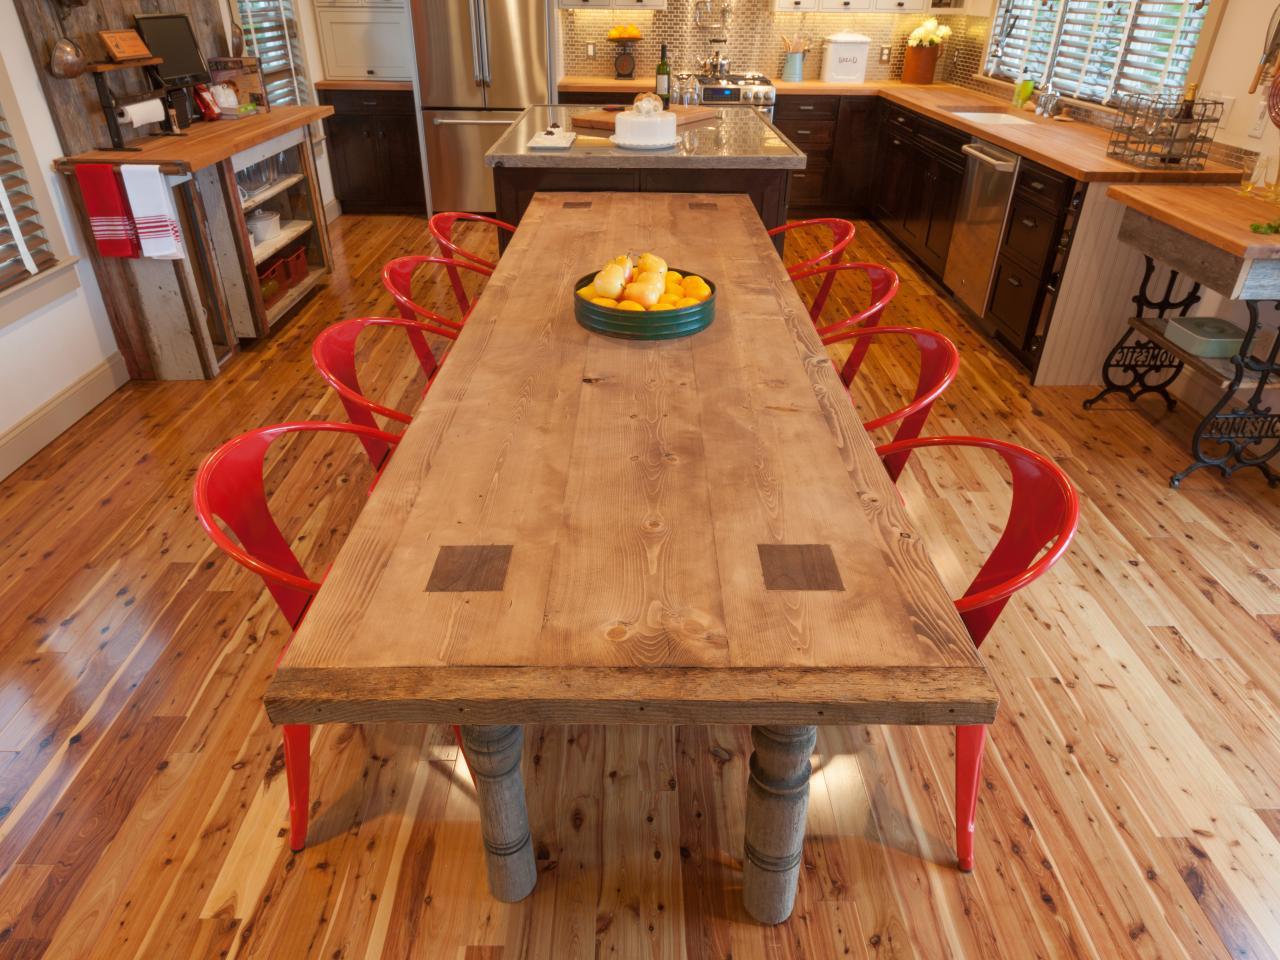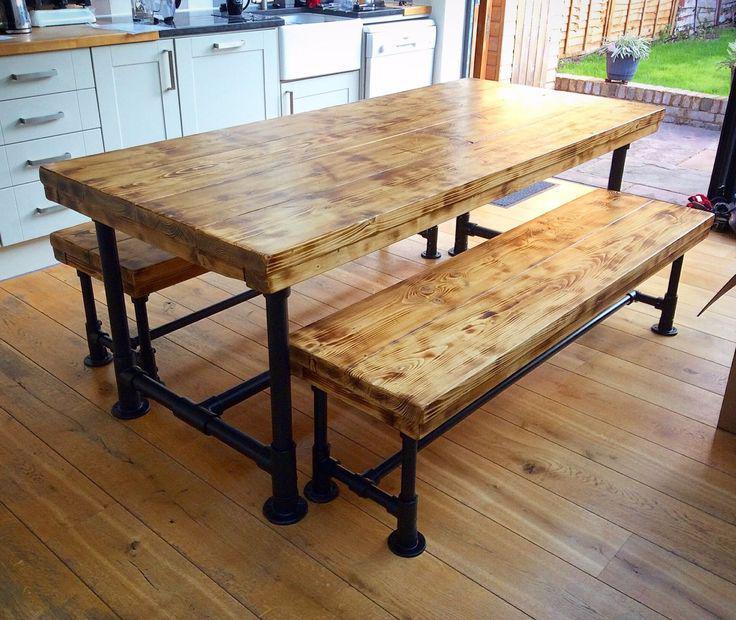The first image is the image on the left, the second image is the image on the right. Evaluate the accuracy of this statement regarding the images: "One table has bench seating.". Is it true? Answer yes or no. Yes. The first image is the image on the left, the second image is the image on the right. Assess this claim about the two images: "There is a bench left of the table in one of the images". Correct or not? Answer yes or no. Yes. 